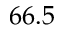Convert formula to latex. <formula><loc_0><loc_0><loc_500><loc_500>6 6 . 5</formula> 